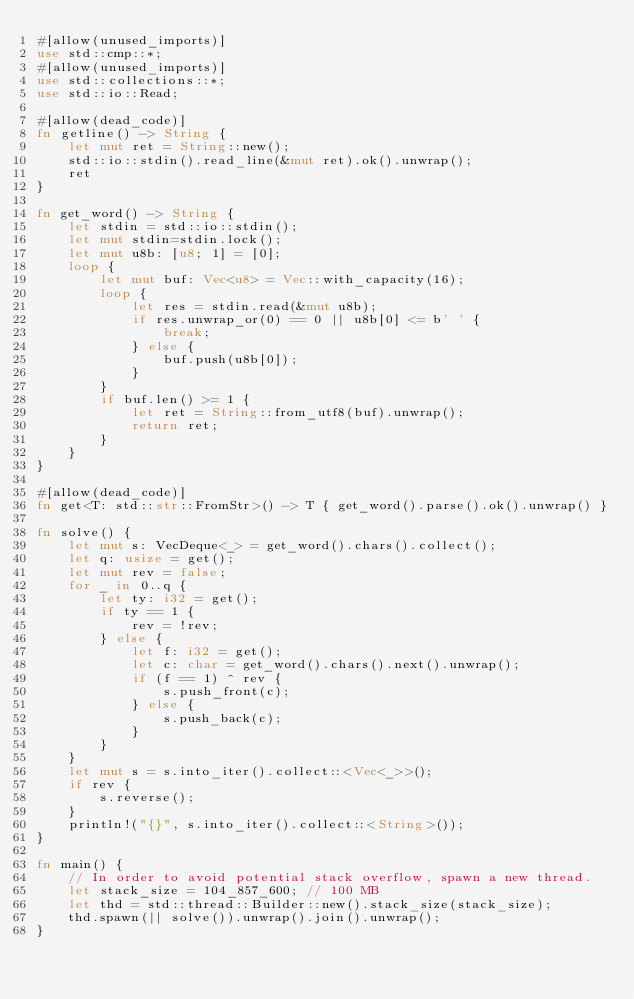Convert code to text. <code><loc_0><loc_0><loc_500><loc_500><_Rust_>#[allow(unused_imports)]
use std::cmp::*;
#[allow(unused_imports)]
use std::collections::*;
use std::io::Read;

#[allow(dead_code)]
fn getline() -> String {
    let mut ret = String::new();
    std::io::stdin().read_line(&mut ret).ok().unwrap();
    ret
}

fn get_word() -> String {
    let stdin = std::io::stdin();
    let mut stdin=stdin.lock();
    let mut u8b: [u8; 1] = [0];
    loop {
        let mut buf: Vec<u8> = Vec::with_capacity(16);
        loop {
            let res = stdin.read(&mut u8b);
            if res.unwrap_or(0) == 0 || u8b[0] <= b' ' {
                break;
            } else {
                buf.push(u8b[0]);
            }
        }
        if buf.len() >= 1 {
            let ret = String::from_utf8(buf).unwrap();
            return ret;
        }
    }
}

#[allow(dead_code)]
fn get<T: std::str::FromStr>() -> T { get_word().parse().ok().unwrap() }

fn solve() {
    let mut s: VecDeque<_> = get_word().chars().collect();
    let q: usize = get();
    let mut rev = false;
    for _ in 0..q {
        let ty: i32 = get();
        if ty == 1 {
            rev = !rev;
        } else {
            let f: i32 = get();
            let c: char = get_word().chars().next().unwrap();
            if (f == 1) ^ rev {
                s.push_front(c);
            } else {
                s.push_back(c);
            }
        }
    }
    let mut s = s.into_iter().collect::<Vec<_>>();
    if rev {
        s.reverse();
    }
    println!("{}", s.into_iter().collect::<String>());
}

fn main() {
    // In order to avoid potential stack overflow, spawn a new thread.
    let stack_size = 104_857_600; // 100 MB
    let thd = std::thread::Builder::new().stack_size(stack_size);
    thd.spawn(|| solve()).unwrap().join().unwrap();
}
</code> 